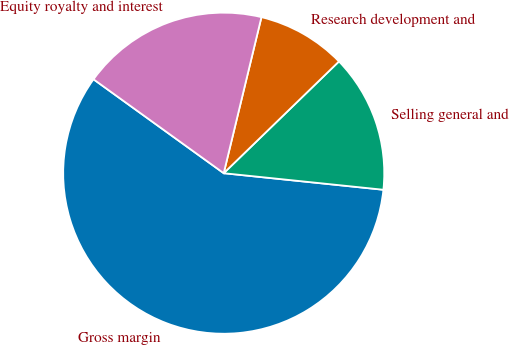Convert chart. <chart><loc_0><loc_0><loc_500><loc_500><pie_chart><fcel>Gross margin<fcel>Selling general and<fcel>Research development and<fcel>Equity royalty and interest<nl><fcel>58.3%<fcel>13.9%<fcel>8.97%<fcel>18.83%<nl></chart> 